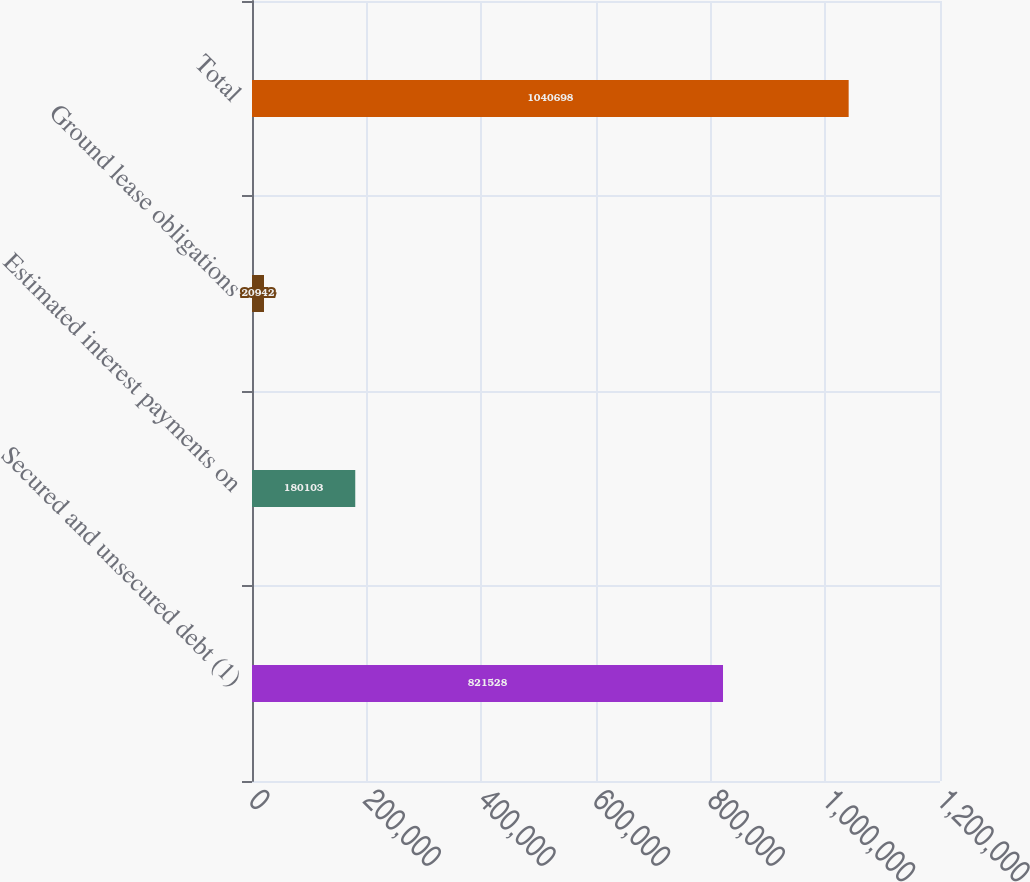<chart> <loc_0><loc_0><loc_500><loc_500><bar_chart><fcel>Secured and unsecured debt (1)<fcel>Estimated interest payments on<fcel>Ground lease obligations<fcel>Total<nl><fcel>821528<fcel>180103<fcel>20942<fcel>1.0407e+06<nl></chart> 